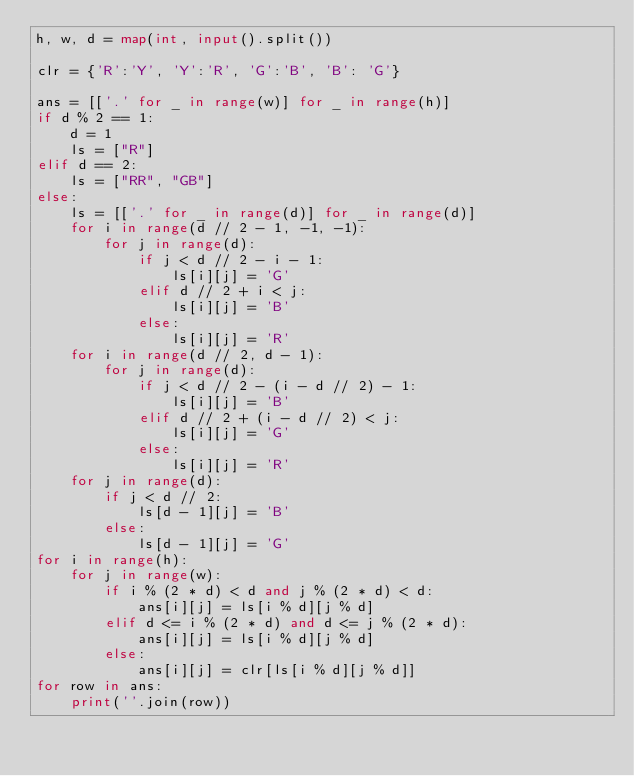Convert code to text. <code><loc_0><loc_0><loc_500><loc_500><_Python_>h, w, d = map(int, input().split())

clr = {'R':'Y', 'Y':'R', 'G':'B', 'B': 'G'}

ans = [['.' for _ in range(w)] for _ in range(h)]
if d % 2 == 1:
    d = 1
    ls = ["R"]
elif d == 2:
    ls = ["RR", "GB"]
else:
    ls = [['.' for _ in range(d)] for _ in range(d)]
    for i in range(d // 2 - 1, -1, -1):
        for j in range(d):
            if j < d // 2 - i - 1:
                ls[i][j] = 'G'
            elif d // 2 + i < j:
                ls[i][j] = 'B'
            else:
                ls[i][j] = 'R'
    for i in range(d // 2, d - 1):
        for j in range(d):
            if j < d // 2 - (i - d // 2) - 1:
                ls[i][j] = 'B'
            elif d // 2 + (i - d // 2) < j:
                ls[i][j] = 'G'
            else:
                ls[i][j] = 'R'
    for j in range(d):
        if j < d // 2:
            ls[d - 1][j] = 'B'
        else:
            ls[d - 1][j] = 'G'
for i in range(h):
    for j in range(w):
        if i % (2 * d) < d and j % (2 * d) < d:
            ans[i][j] = ls[i % d][j % d]
        elif d <= i % (2 * d) and d <= j % (2 * d):
            ans[i][j] = ls[i % d][j % d]
        else:
            ans[i][j] = clr[ls[i % d][j % d]]
for row in ans:
    print(''.join(row))</code> 